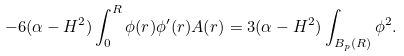<formula> <loc_0><loc_0><loc_500><loc_500>- 6 ( \alpha - H ^ { 2 } ) \int _ { 0 } ^ { R } \phi ( r ) \phi ^ { \prime } ( r ) A ( r ) = 3 ( \alpha - H ^ { 2 } ) \int _ { B _ { p } ( R ) } \phi ^ { 2 } .</formula> 